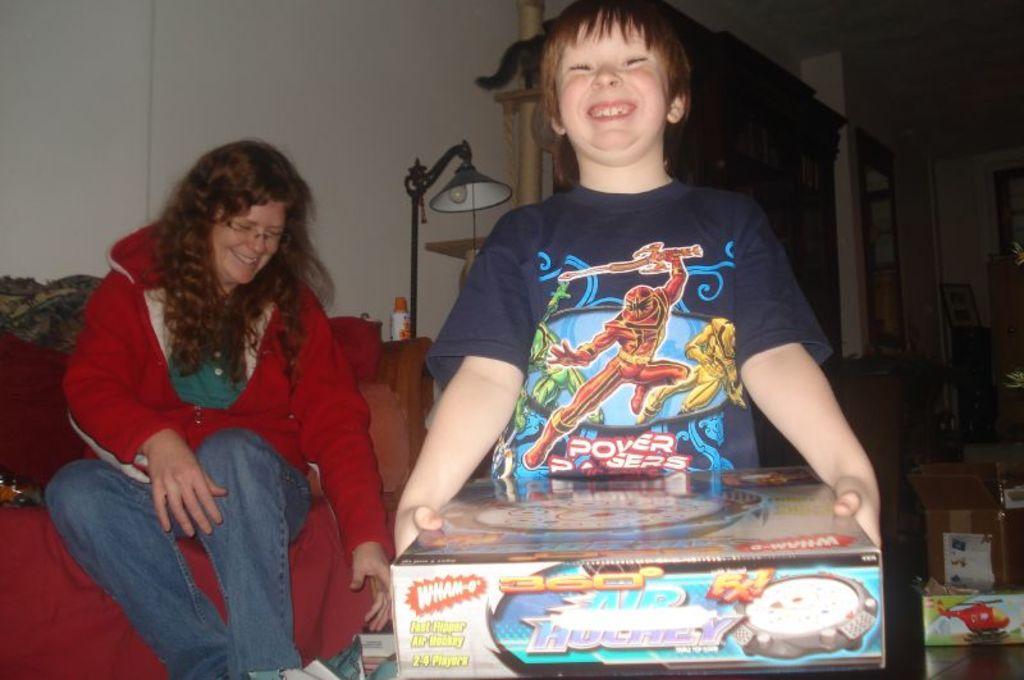Can you describe this image briefly? In this image, there are a few people. Among them, we can see a person sitting and a person is holding some object. We can see the wall and a light. We can also see some wooden objects. We can see a cardboard box and some objects on the right. We can see the wall and some objects. 